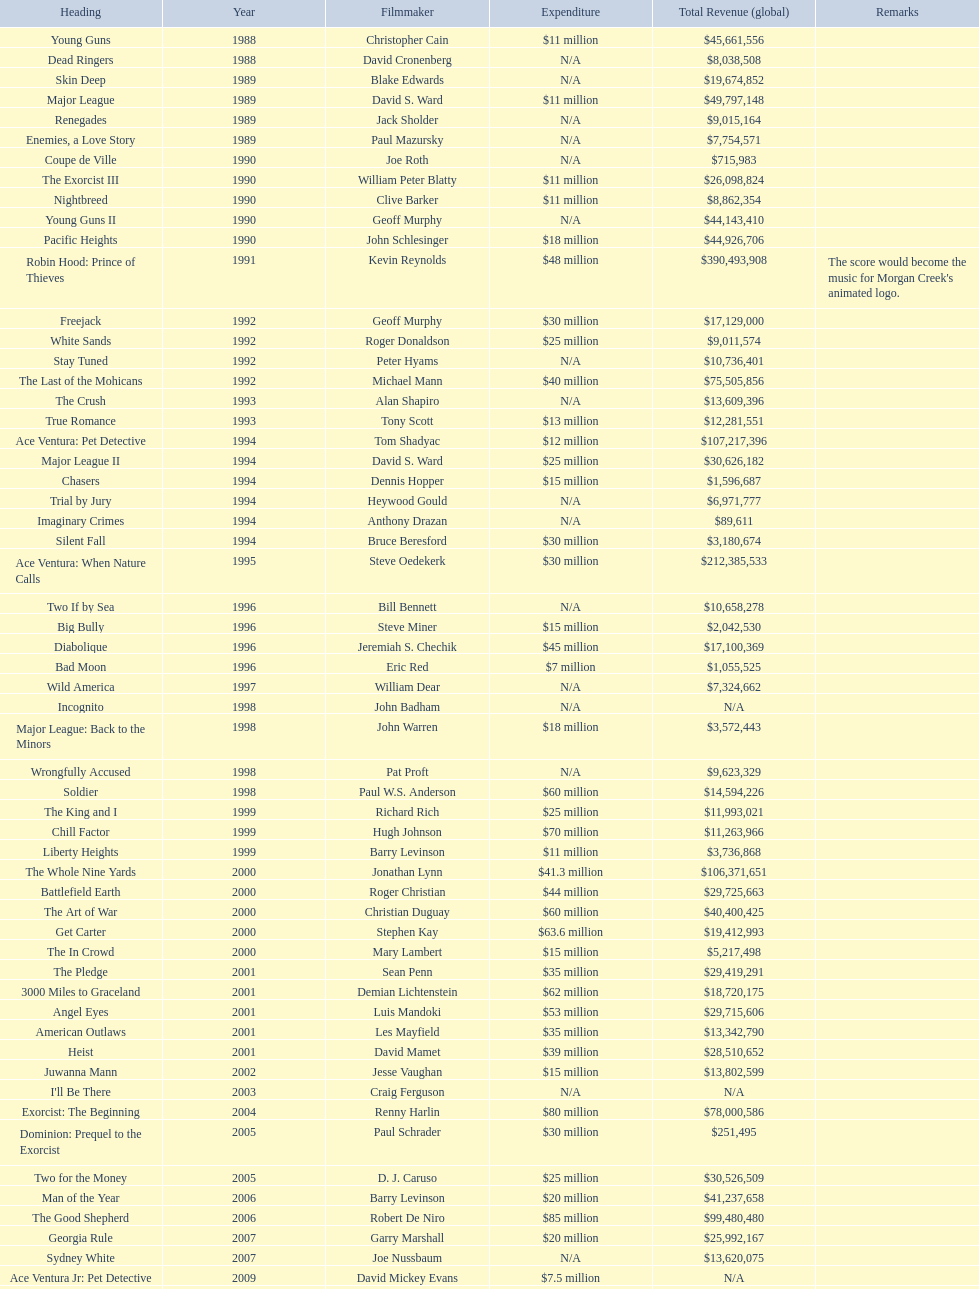Which single film had a budget of 48 million dollars? Robin Hood: Prince of Thieves. 